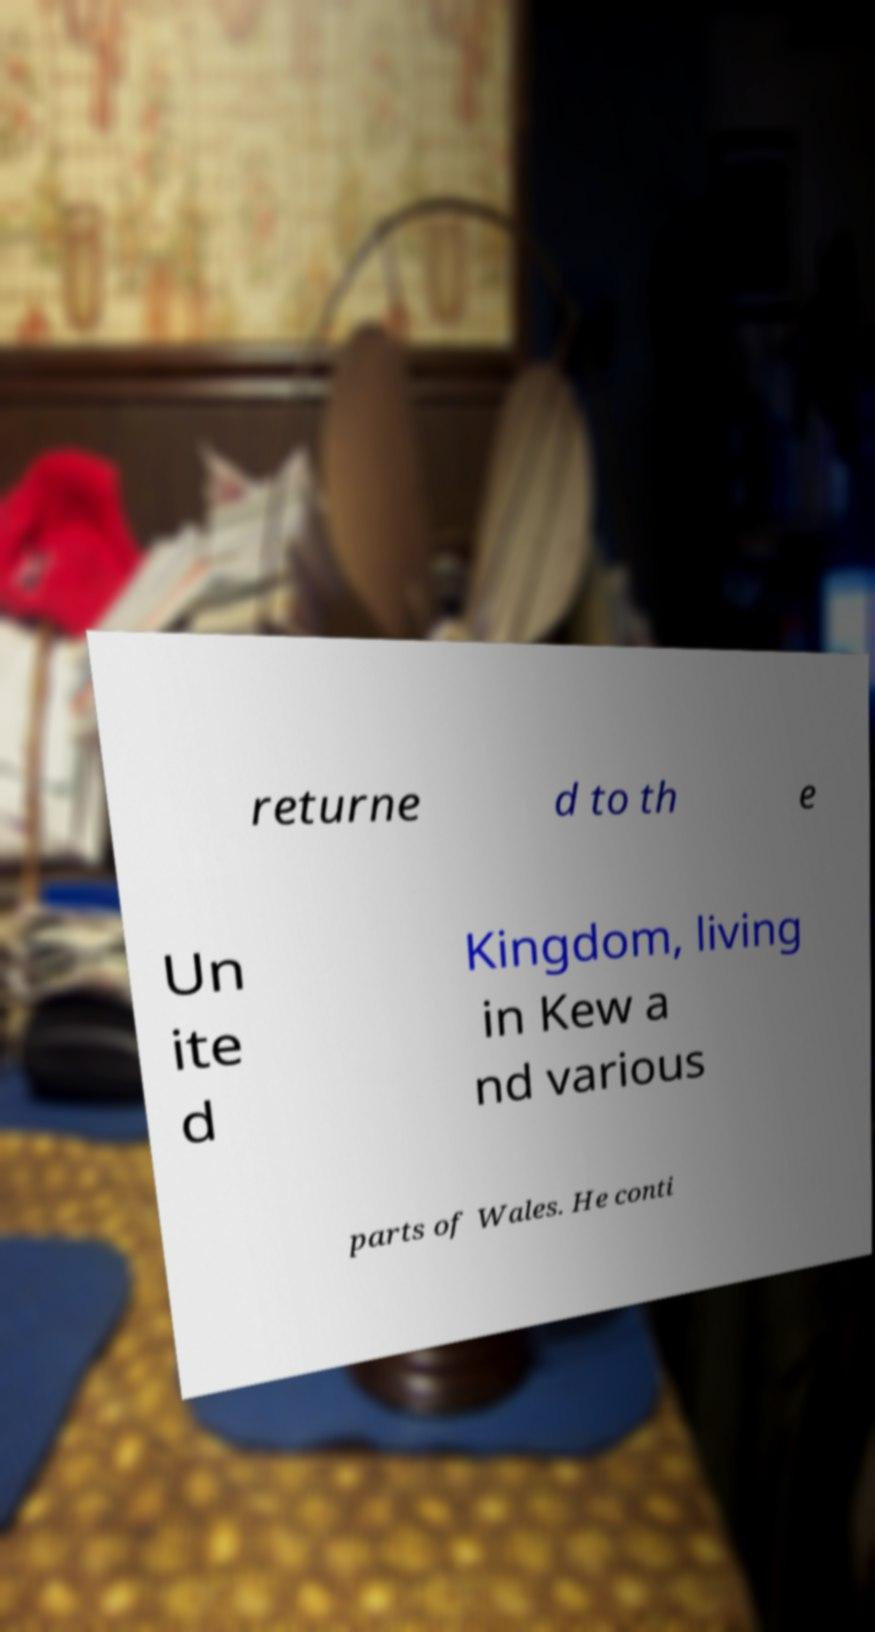For documentation purposes, I need the text within this image transcribed. Could you provide that? returne d to th e Un ite d Kingdom, living in Kew a nd various parts of Wales. He conti 